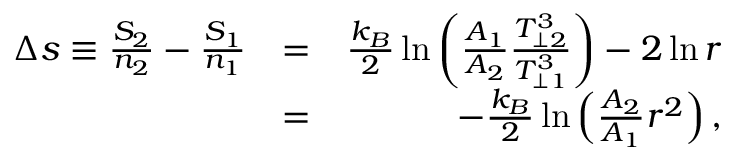Convert formula to latex. <formula><loc_0><loc_0><loc_500><loc_500>\begin{array} { r l r } { \Delta s \equiv \frac { S _ { 2 } } { n _ { 2 } } - \frac { S _ { 1 } } { n _ { 1 } } } & { = } & { \frac { k _ { B } } { 2 } \ln \left ( \frac { A _ { 1 } } { A _ { 2 } } \frac { T _ { \perp 2 } ^ { 3 } } { T _ { \perp 1 } ^ { 3 } } \right ) - 2 \ln r } \\ & { = } & { - \frac { k _ { B } } { 2 } \ln \left ( \frac { A _ { 2 } } { A _ { 1 } } r ^ { 2 } \right ) , } \end{array}</formula> 